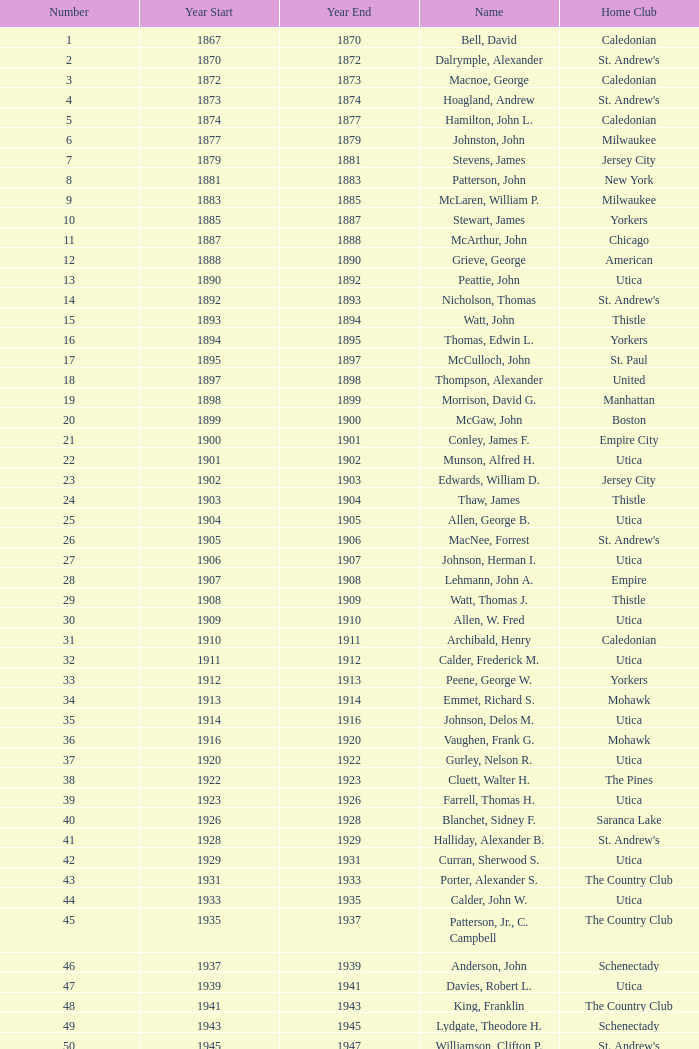Which number is associated with a home club called broomstones and has a year-end less than 1999? None. 